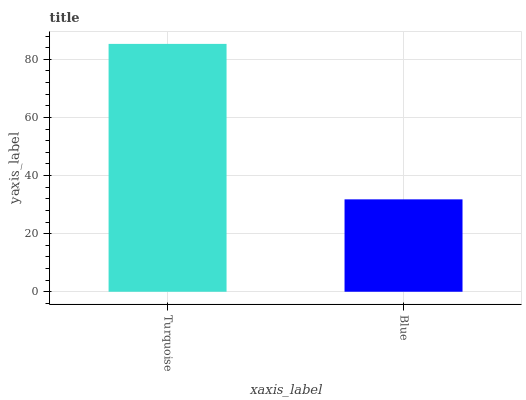Is Blue the minimum?
Answer yes or no. Yes. Is Turquoise the maximum?
Answer yes or no. Yes. Is Blue the maximum?
Answer yes or no. No. Is Turquoise greater than Blue?
Answer yes or no. Yes. Is Blue less than Turquoise?
Answer yes or no. Yes. Is Blue greater than Turquoise?
Answer yes or no. No. Is Turquoise less than Blue?
Answer yes or no. No. Is Turquoise the high median?
Answer yes or no. Yes. Is Blue the low median?
Answer yes or no. Yes. Is Blue the high median?
Answer yes or no. No. Is Turquoise the low median?
Answer yes or no. No. 